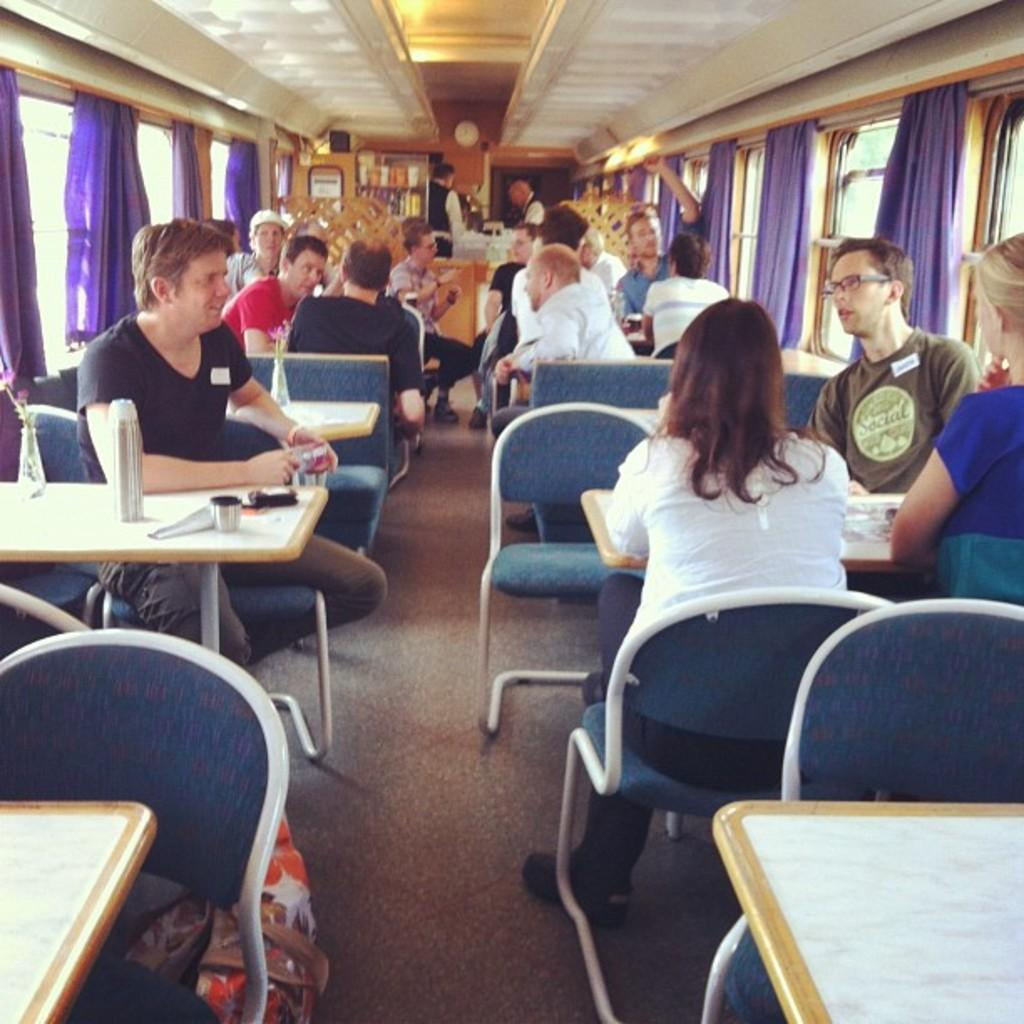What are the people in the image doing? People are sitting on chairs around tables. What can be seen on the sides of the tables? There are windows on the left and right sides of the tables. What type of window treatment is present on the windows? Purple curtains are present on the windows. Can you describe the staff in the image? There are two waiters standing at the back. What type of music is being played in the background of the image? There is no information about music in the image, as it focuses on the people, tables, windows, curtains, and waiters. 